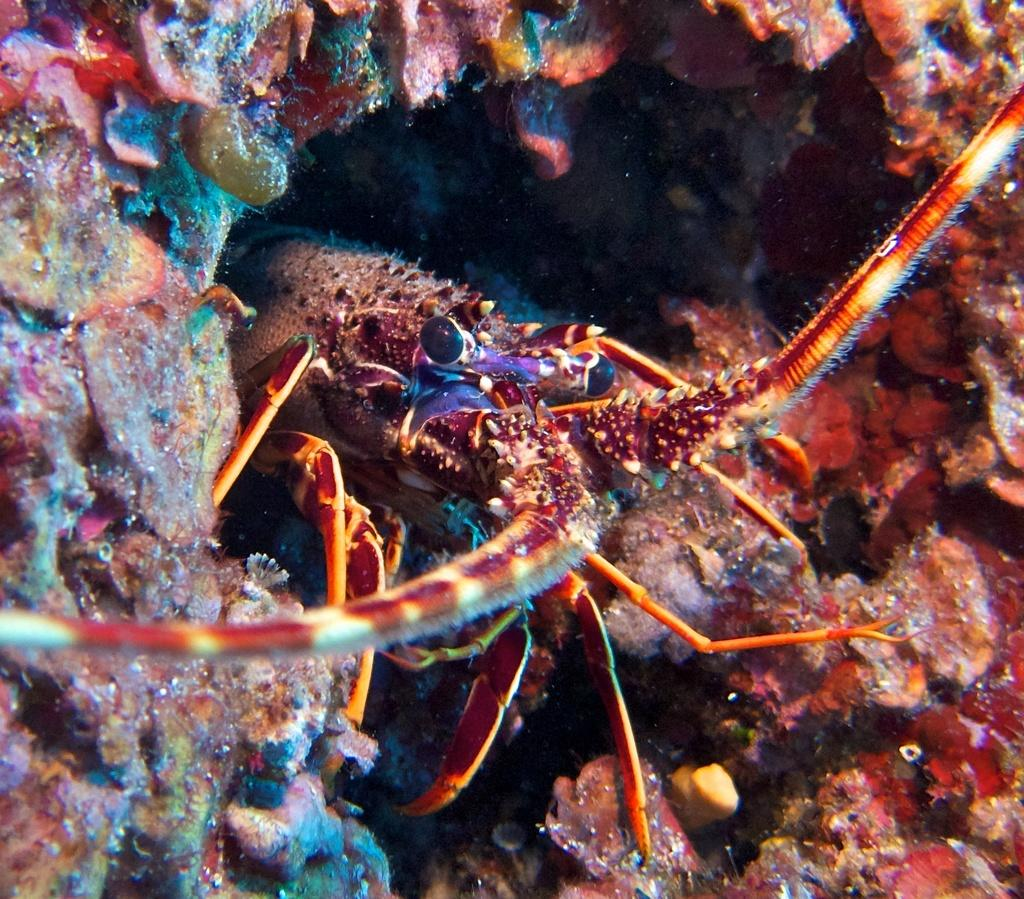What is the main subject in the center of the image? There is an animal in the center of the image. Can you describe the surrounding area of the animal? There is a layer with different colors surrounding the animal. How many buns are being held by the animal's toes in the image? There are no buns or toes present in the image, as it features an animal surrounded by a layer of different colors. 